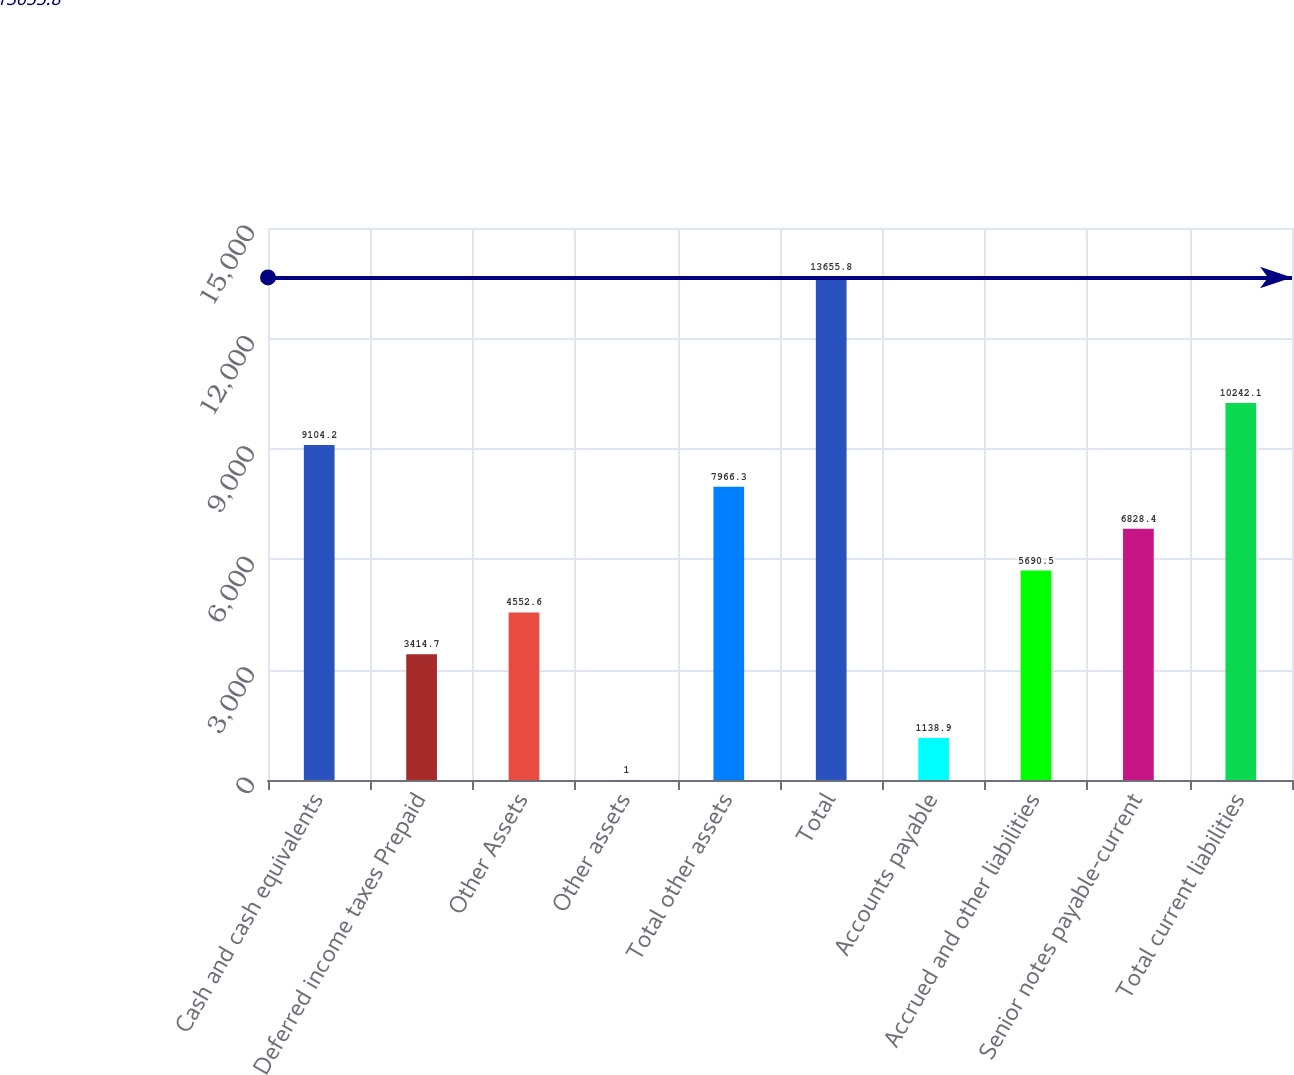Convert chart. <chart><loc_0><loc_0><loc_500><loc_500><bar_chart><fcel>Cash and cash equivalents<fcel>Deferred income taxes Prepaid<fcel>Other Assets<fcel>Other assets<fcel>Total other assets<fcel>Total<fcel>Accounts payable<fcel>Accrued and other liabilities<fcel>Senior notes payable-current<fcel>Total current liabilities<nl><fcel>9104.2<fcel>3414.7<fcel>4552.6<fcel>1<fcel>7966.3<fcel>13655.8<fcel>1138.9<fcel>5690.5<fcel>6828.4<fcel>10242.1<nl></chart> 